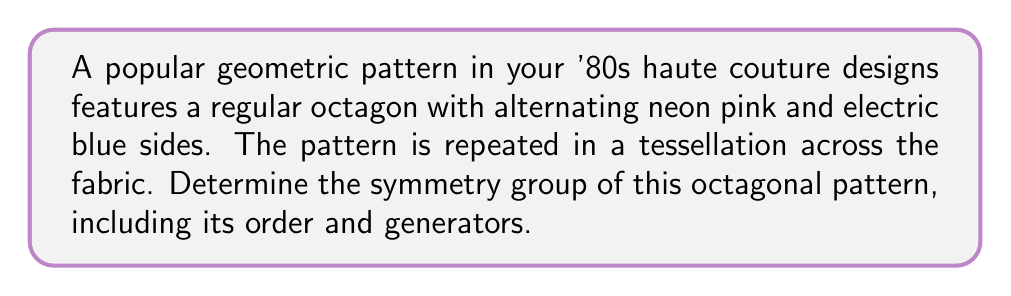Help me with this question. To determine the symmetry group of this octagonal pattern, we need to consider all the symmetry operations that leave the pattern unchanged. Let's approach this step-by-step:

1. Rotational symmetries:
   The regular octagon has 8-fold rotational symmetry. This means it can be rotated by multiples of 45° (360°/8) and remain unchanged.

2. Reflection symmetries:
   The octagon has 8 lines of reflection symmetry: 4 passing through opposite vertices and 4 passing through the midpoints of opposite sides.

3. Symmetry group identification:
   The symmetry group of a regular octagon is known as the dihedral group of order 16, denoted as $D_8$ or $D_{16}$ (depending on the naming convention).

4. Order of the group:
   The order of $D_8$ is 16, which can be calculated as follows:
   - 8 rotations (including the identity rotation)
   - 8 reflections

5. Generators of the group:
   The dihedral group $D_8$ can be generated by two elements:
   - $r$: rotation by 45° (counterclockwise)
   - $s$: reflection about a line of symmetry

   We can express this as: $D_8 = \langle r, s \mid r^8 = s^2 = 1, srs = r^{-1} \rangle$

6. Elements of the group:
   The 16 elements of $D_8$ can be written as:
   $$\{1, r, r^2, r^3, r^4, r^5, r^6, r^7, s, sr, sr^2, sr^3, sr^4, sr^5, sr^6, sr^7\}$$

   Where $1$ represents the identity transformation, $r^i$ represents rotation by $i \cdot 45°$, and $sr^i$ represents reflection followed by rotation.

The alternating neon pink and electric blue sides do not affect the symmetry group, as they follow the same symmetry as the octagon itself.

[asy]
import geometry;

size(200);
pen pink = rgb(1,0.4,0.7);
pen blue = rgb(0,0.6,1);

path oct = polygon(8);
for(int i=0; i<8; ++i) {
  draw(rotate(45*i)*oct, (i%2==0 ? pink : blue)+linewidth(2));
}

for(int i=0; i<4; ++i) {
  draw(rotate(45*i)*((1,0)--(0,0)--(0.7071,0.7071)), dashed);
}
</asy>

This diagram illustrates the octagonal pattern with alternating colors and its lines of symmetry (dashed lines).
Answer: The symmetry group of the octagonal pattern is the dihedral group $D_8$ (or $D_{16}$), with order 16. It is generated by a rotation $r$ of 45° and a reflection $s$, satisfying $r^8 = s^2 = 1$ and $srs = r^{-1}$. 